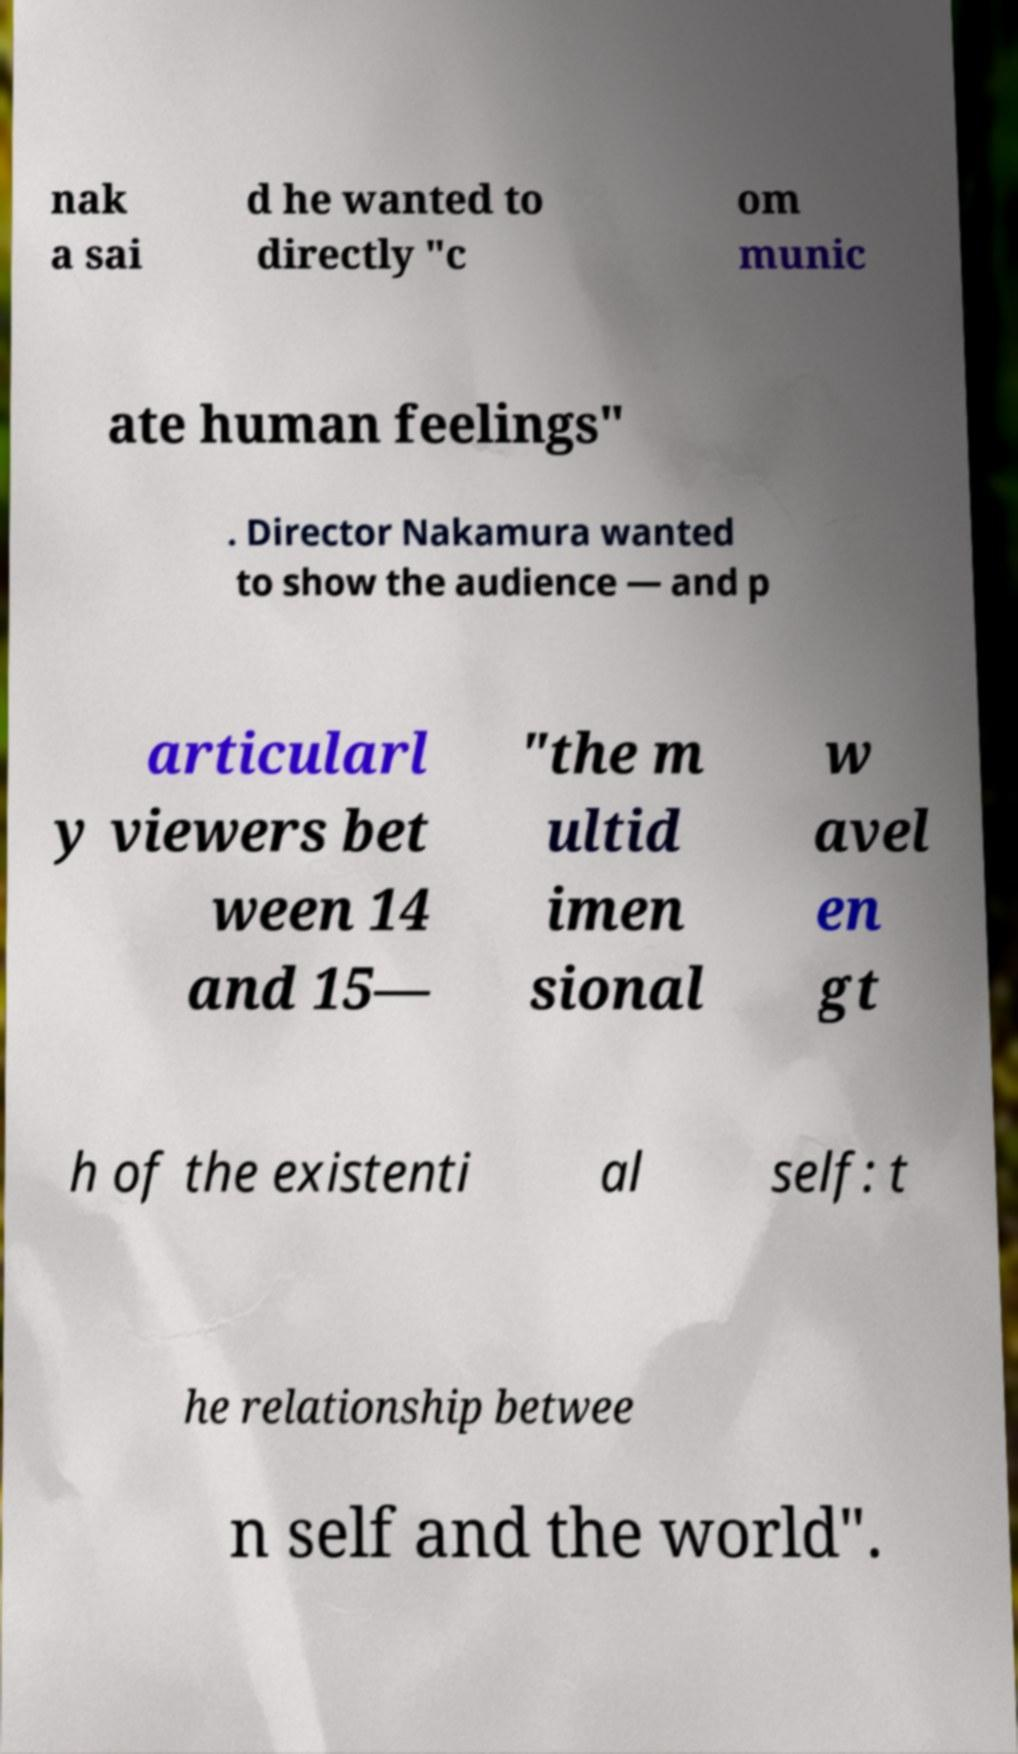Could you extract and type out the text from this image? nak a sai d he wanted to directly "c om munic ate human feelings" . Director Nakamura wanted to show the audience — and p articularl y viewers bet ween 14 and 15— "the m ultid imen sional w avel en gt h of the existenti al self: t he relationship betwee n self and the world". 